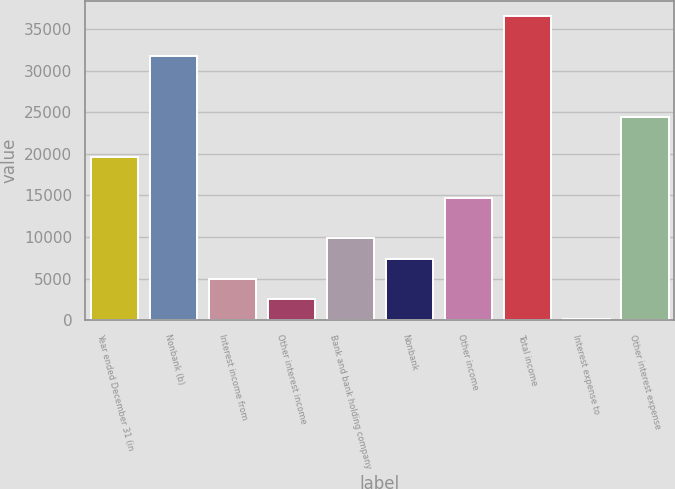Convert chart. <chart><loc_0><loc_0><loc_500><loc_500><bar_chart><fcel>Year ended December 31 (in<fcel>Nonbank (b)<fcel>Interest income from<fcel>Other interest income<fcel>Bank and bank holding company<fcel>Nonbank<fcel>Other income<fcel>Total income<fcel>Interest expense to<fcel>Other interest expense<nl><fcel>19573.2<fcel>31745.2<fcel>4966.8<fcel>2532.4<fcel>9835.6<fcel>7401.2<fcel>14704.4<fcel>36614<fcel>98<fcel>24442<nl></chart> 